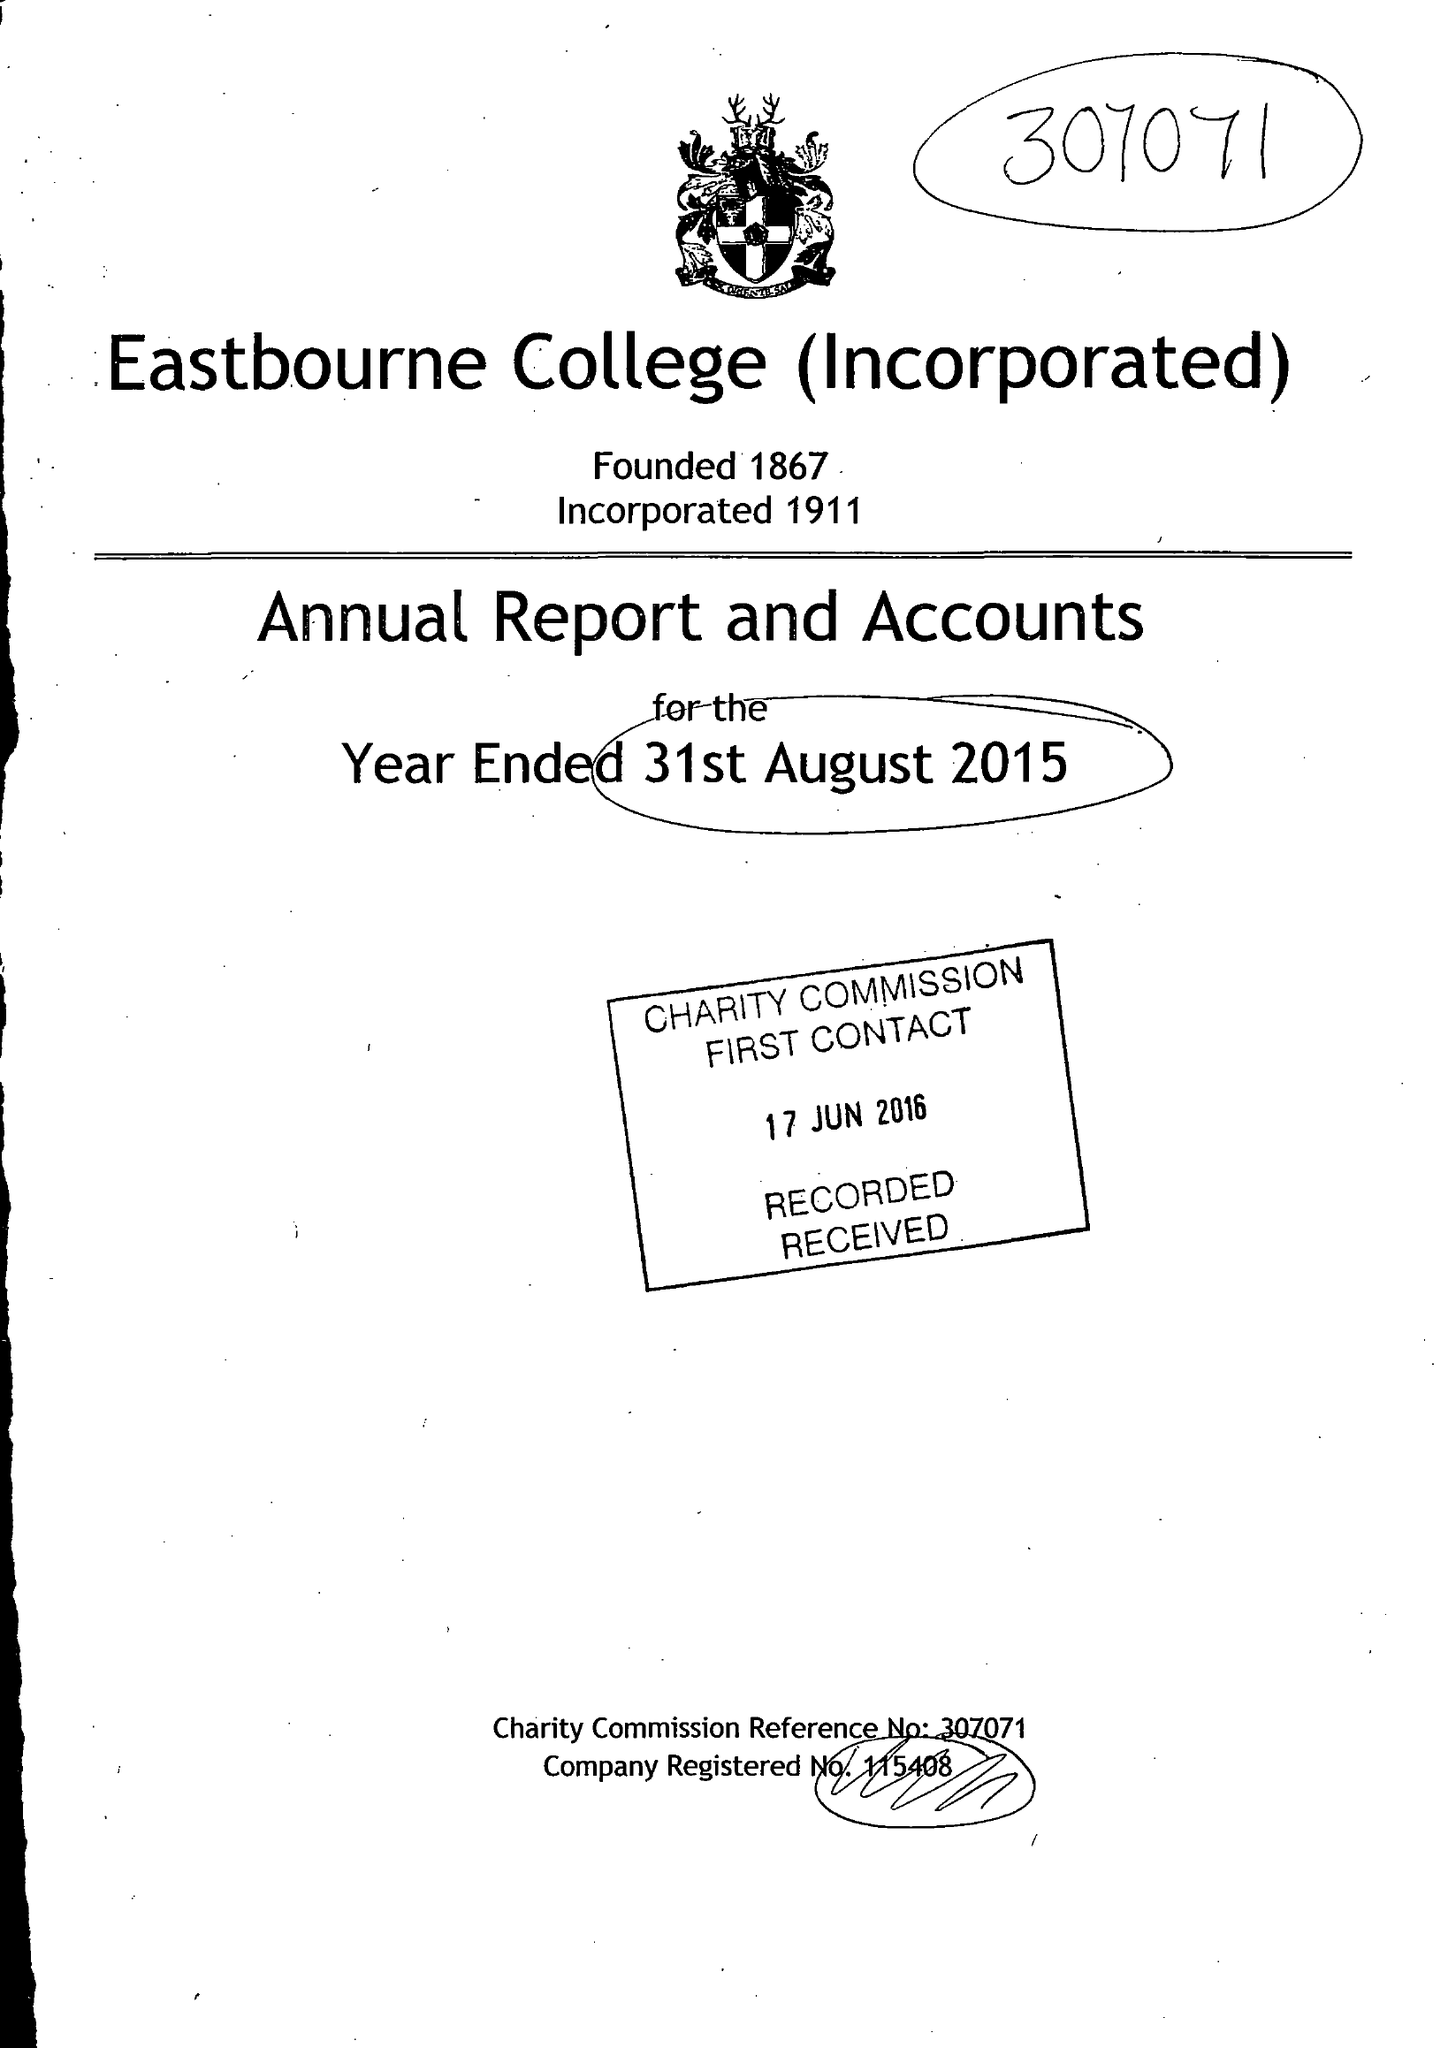What is the value for the address__postcode?
Answer the question using a single word or phrase. BN21 4JY 